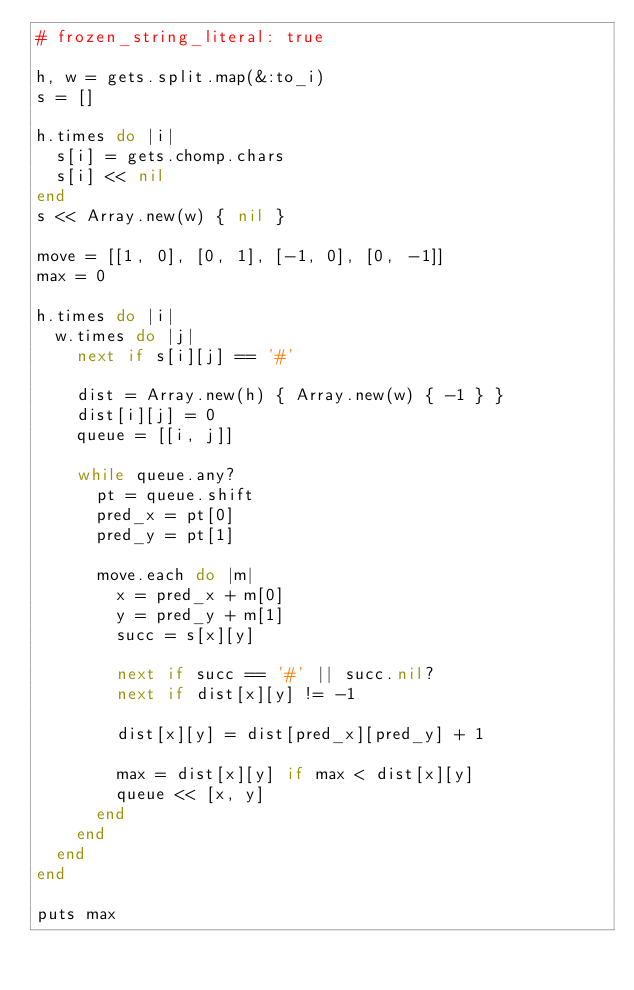<code> <loc_0><loc_0><loc_500><loc_500><_Ruby_># frozen_string_literal: true

h, w = gets.split.map(&:to_i)
s = []

h.times do |i|
  s[i] = gets.chomp.chars
  s[i] << nil
end
s << Array.new(w) { nil }

move = [[1, 0], [0, 1], [-1, 0], [0, -1]]
max = 0

h.times do |i|
  w.times do |j|
    next if s[i][j] == '#'

    dist = Array.new(h) { Array.new(w) { -1 } }
    dist[i][j] = 0
    queue = [[i, j]]

    while queue.any?
      pt = queue.shift
      pred_x = pt[0]
      pred_y = pt[1]

      move.each do |m|
        x = pred_x + m[0]
        y = pred_y + m[1]
        succ = s[x][y]

        next if succ == '#' || succ.nil?
        next if dist[x][y] != -1

        dist[x][y] = dist[pred_x][pred_y] + 1

        max = dist[x][y] if max < dist[x][y]
        queue << [x, y]
      end
    end
  end
end

puts max</code> 